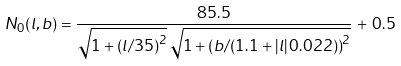Convert formula to latex. <formula><loc_0><loc_0><loc_500><loc_500>N _ { 0 } ( l , b ) = \frac { 8 5 . 5 } { \sqrt { 1 + \left ( l / 3 5 \right ) ^ { 2 } } \, \sqrt { 1 + \left ( b / ( 1 . 1 + | l | \, 0 . 0 2 2 ) \right ) ^ { 2 } } } \, + \, 0 . 5</formula> 